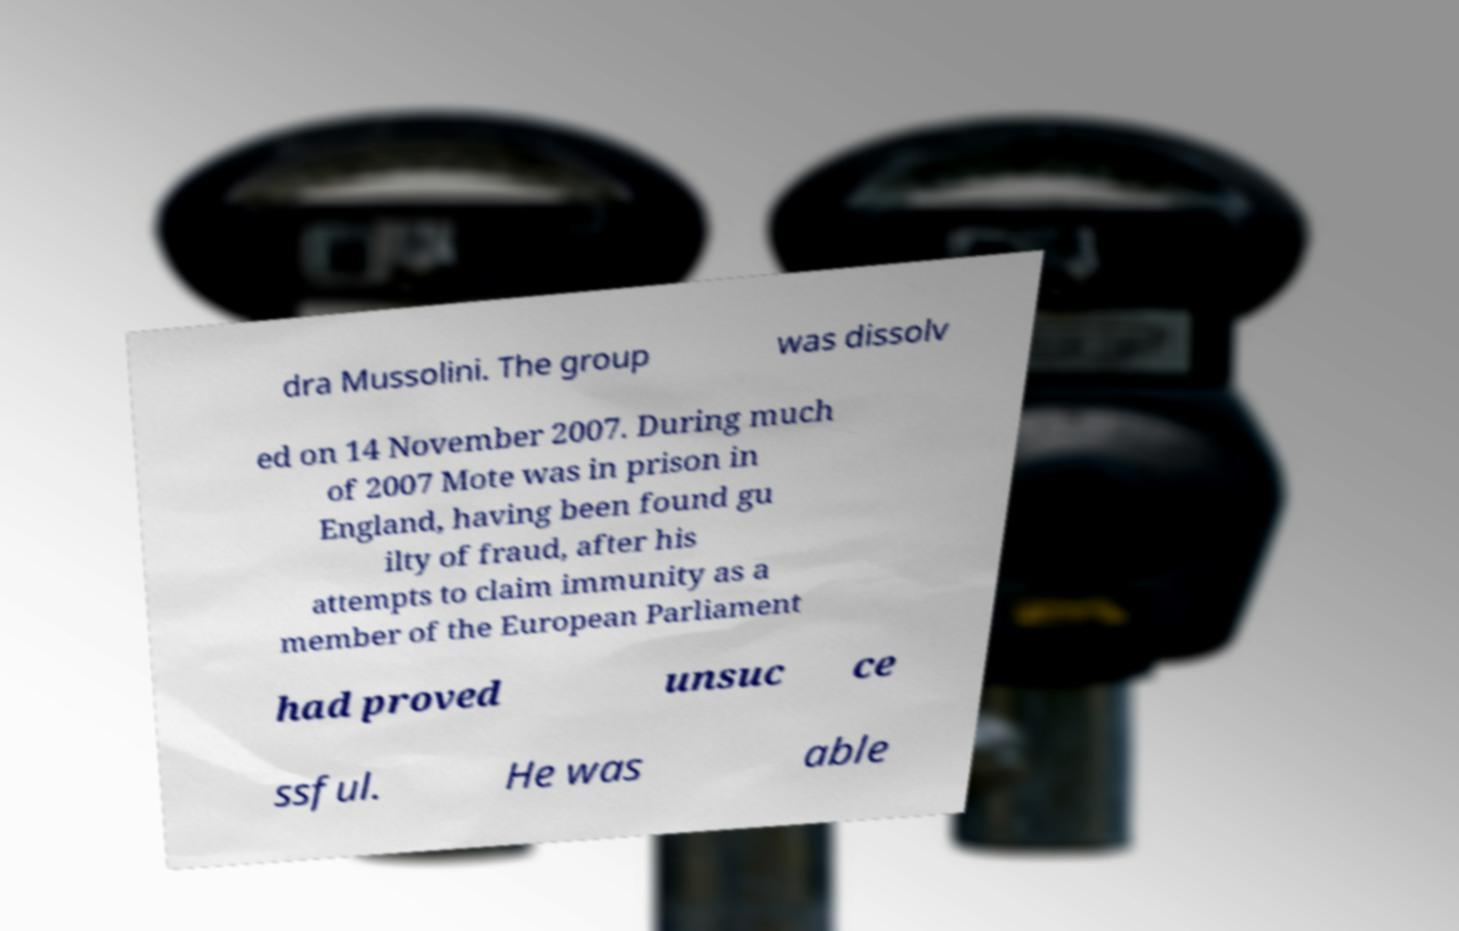For documentation purposes, I need the text within this image transcribed. Could you provide that? dra Mussolini. The group was dissolv ed on 14 November 2007. During much of 2007 Mote was in prison in England, having been found gu ilty of fraud, after his attempts to claim immunity as a member of the European Parliament had proved unsuc ce ssful. He was able 